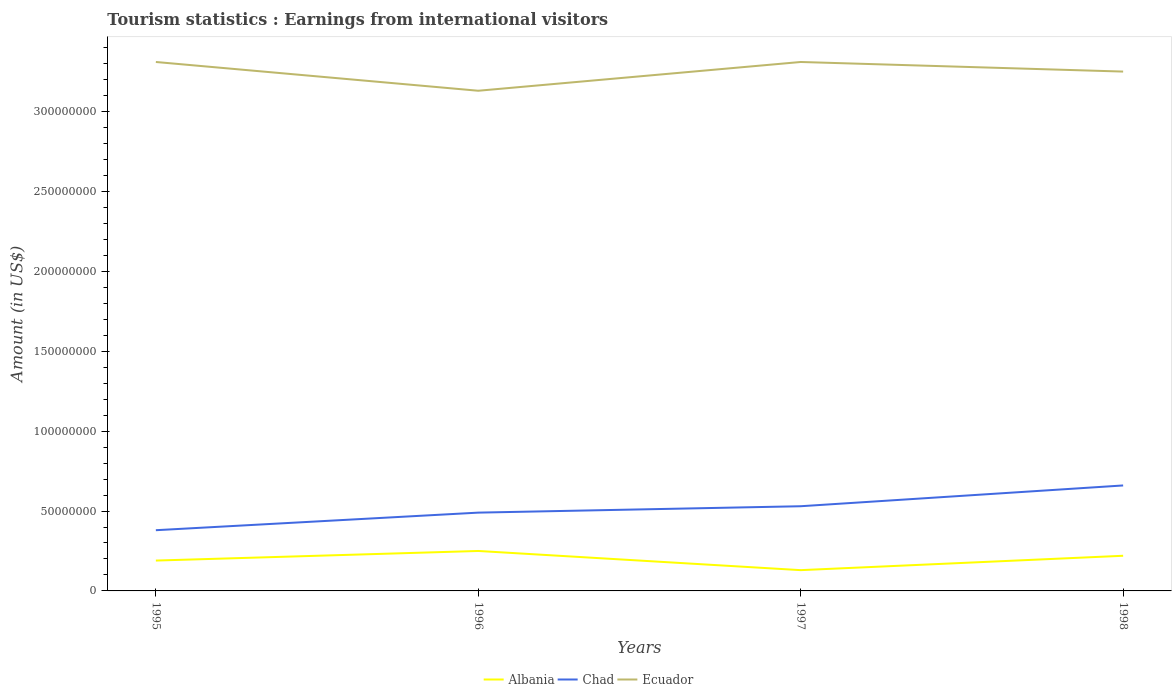How many different coloured lines are there?
Your response must be concise. 3. Does the line corresponding to Albania intersect with the line corresponding to Chad?
Keep it short and to the point. No. Across all years, what is the maximum earnings from international visitors in Albania?
Your response must be concise. 1.30e+07. In which year was the earnings from international visitors in Chad maximum?
Keep it short and to the point. 1995. What is the total earnings from international visitors in Chad in the graph?
Offer a very short reply. -1.30e+07. What is the difference between the highest and the second highest earnings from international visitors in Chad?
Your answer should be compact. 2.80e+07. What is the difference between the highest and the lowest earnings from international visitors in Chad?
Your answer should be very brief. 2. Is the earnings from international visitors in Albania strictly greater than the earnings from international visitors in Chad over the years?
Your answer should be very brief. Yes. How many lines are there?
Provide a short and direct response. 3. What is the difference between two consecutive major ticks on the Y-axis?
Your response must be concise. 5.00e+07. Are the values on the major ticks of Y-axis written in scientific E-notation?
Give a very brief answer. No. Does the graph contain grids?
Offer a very short reply. No. Where does the legend appear in the graph?
Your answer should be very brief. Bottom center. How many legend labels are there?
Give a very brief answer. 3. What is the title of the graph?
Make the answer very short. Tourism statistics : Earnings from international visitors. What is the label or title of the X-axis?
Make the answer very short. Years. What is the Amount (in US$) of Albania in 1995?
Keep it short and to the point. 1.90e+07. What is the Amount (in US$) in Chad in 1995?
Offer a very short reply. 3.80e+07. What is the Amount (in US$) of Ecuador in 1995?
Make the answer very short. 3.31e+08. What is the Amount (in US$) in Albania in 1996?
Keep it short and to the point. 2.50e+07. What is the Amount (in US$) of Chad in 1996?
Ensure brevity in your answer.  4.90e+07. What is the Amount (in US$) in Ecuador in 1996?
Give a very brief answer. 3.13e+08. What is the Amount (in US$) in Albania in 1997?
Offer a very short reply. 1.30e+07. What is the Amount (in US$) of Chad in 1997?
Give a very brief answer. 5.30e+07. What is the Amount (in US$) of Ecuador in 1997?
Provide a short and direct response. 3.31e+08. What is the Amount (in US$) of Albania in 1998?
Give a very brief answer. 2.20e+07. What is the Amount (in US$) of Chad in 1998?
Keep it short and to the point. 6.60e+07. What is the Amount (in US$) in Ecuador in 1998?
Provide a succinct answer. 3.25e+08. Across all years, what is the maximum Amount (in US$) of Albania?
Provide a succinct answer. 2.50e+07. Across all years, what is the maximum Amount (in US$) of Chad?
Provide a short and direct response. 6.60e+07. Across all years, what is the maximum Amount (in US$) in Ecuador?
Make the answer very short. 3.31e+08. Across all years, what is the minimum Amount (in US$) in Albania?
Offer a very short reply. 1.30e+07. Across all years, what is the minimum Amount (in US$) of Chad?
Your response must be concise. 3.80e+07. Across all years, what is the minimum Amount (in US$) of Ecuador?
Keep it short and to the point. 3.13e+08. What is the total Amount (in US$) in Albania in the graph?
Provide a succinct answer. 7.90e+07. What is the total Amount (in US$) in Chad in the graph?
Make the answer very short. 2.06e+08. What is the total Amount (in US$) of Ecuador in the graph?
Provide a short and direct response. 1.30e+09. What is the difference between the Amount (in US$) of Albania in 1995 and that in 1996?
Provide a succinct answer. -6.00e+06. What is the difference between the Amount (in US$) of Chad in 1995 and that in 1996?
Offer a terse response. -1.10e+07. What is the difference between the Amount (in US$) in Ecuador in 1995 and that in 1996?
Your response must be concise. 1.80e+07. What is the difference between the Amount (in US$) in Chad in 1995 and that in 1997?
Ensure brevity in your answer.  -1.50e+07. What is the difference between the Amount (in US$) of Albania in 1995 and that in 1998?
Make the answer very short. -3.00e+06. What is the difference between the Amount (in US$) of Chad in 1995 and that in 1998?
Keep it short and to the point. -2.80e+07. What is the difference between the Amount (in US$) of Ecuador in 1996 and that in 1997?
Provide a succinct answer. -1.80e+07. What is the difference between the Amount (in US$) in Chad in 1996 and that in 1998?
Provide a short and direct response. -1.70e+07. What is the difference between the Amount (in US$) of Ecuador in 1996 and that in 1998?
Provide a succinct answer. -1.20e+07. What is the difference between the Amount (in US$) in Albania in 1997 and that in 1998?
Your answer should be very brief. -9.00e+06. What is the difference between the Amount (in US$) of Chad in 1997 and that in 1998?
Offer a very short reply. -1.30e+07. What is the difference between the Amount (in US$) in Ecuador in 1997 and that in 1998?
Ensure brevity in your answer.  6.00e+06. What is the difference between the Amount (in US$) in Albania in 1995 and the Amount (in US$) in Chad in 1996?
Ensure brevity in your answer.  -3.00e+07. What is the difference between the Amount (in US$) of Albania in 1995 and the Amount (in US$) of Ecuador in 1996?
Your answer should be very brief. -2.94e+08. What is the difference between the Amount (in US$) in Chad in 1995 and the Amount (in US$) in Ecuador in 1996?
Offer a terse response. -2.75e+08. What is the difference between the Amount (in US$) of Albania in 1995 and the Amount (in US$) of Chad in 1997?
Provide a succinct answer. -3.40e+07. What is the difference between the Amount (in US$) in Albania in 1995 and the Amount (in US$) in Ecuador in 1997?
Give a very brief answer. -3.12e+08. What is the difference between the Amount (in US$) of Chad in 1995 and the Amount (in US$) of Ecuador in 1997?
Make the answer very short. -2.93e+08. What is the difference between the Amount (in US$) of Albania in 1995 and the Amount (in US$) of Chad in 1998?
Offer a very short reply. -4.70e+07. What is the difference between the Amount (in US$) in Albania in 1995 and the Amount (in US$) in Ecuador in 1998?
Keep it short and to the point. -3.06e+08. What is the difference between the Amount (in US$) of Chad in 1995 and the Amount (in US$) of Ecuador in 1998?
Your answer should be very brief. -2.87e+08. What is the difference between the Amount (in US$) in Albania in 1996 and the Amount (in US$) in Chad in 1997?
Provide a short and direct response. -2.80e+07. What is the difference between the Amount (in US$) in Albania in 1996 and the Amount (in US$) in Ecuador in 1997?
Provide a succinct answer. -3.06e+08. What is the difference between the Amount (in US$) in Chad in 1996 and the Amount (in US$) in Ecuador in 1997?
Offer a terse response. -2.82e+08. What is the difference between the Amount (in US$) in Albania in 1996 and the Amount (in US$) in Chad in 1998?
Keep it short and to the point. -4.10e+07. What is the difference between the Amount (in US$) of Albania in 1996 and the Amount (in US$) of Ecuador in 1998?
Offer a terse response. -3.00e+08. What is the difference between the Amount (in US$) of Chad in 1996 and the Amount (in US$) of Ecuador in 1998?
Your answer should be very brief. -2.76e+08. What is the difference between the Amount (in US$) in Albania in 1997 and the Amount (in US$) in Chad in 1998?
Your response must be concise. -5.30e+07. What is the difference between the Amount (in US$) in Albania in 1997 and the Amount (in US$) in Ecuador in 1998?
Offer a terse response. -3.12e+08. What is the difference between the Amount (in US$) in Chad in 1997 and the Amount (in US$) in Ecuador in 1998?
Give a very brief answer. -2.72e+08. What is the average Amount (in US$) of Albania per year?
Offer a very short reply. 1.98e+07. What is the average Amount (in US$) in Chad per year?
Offer a very short reply. 5.15e+07. What is the average Amount (in US$) of Ecuador per year?
Provide a succinct answer. 3.25e+08. In the year 1995, what is the difference between the Amount (in US$) of Albania and Amount (in US$) of Chad?
Your response must be concise. -1.90e+07. In the year 1995, what is the difference between the Amount (in US$) in Albania and Amount (in US$) in Ecuador?
Your response must be concise. -3.12e+08. In the year 1995, what is the difference between the Amount (in US$) in Chad and Amount (in US$) in Ecuador?
Offer a very short reply. -2.93e+08. In the year 1996, what is the difference between the Amount (in US$) in Albania and Amount (in US$) in Chad?
Offer a terse response. -2.40e+07. In the year 1996, what is the difference between the Amount (in US$) of Albania and Amount (in US$) of Ecuador?
Offer a terse response. -2.88e+08. In the year 1996, what is the difference between the Amount (in US$) in Chad and Amount (in US$) in Ecuador?
Ensure brevity in your answer.  -2.64e+08. In the year 1997, what is the difference between the Amount (in US$) of Albania and Amount (in US$) of Chad?
Offer a terse response. -4.00e+07. In the year 1997, what is the difference between the Amount (in US$) in Albania and Amount (in US$) in Ecuador?
Provide a succinct answer. -3.18e+08. In the year 1997, what is the difference between the Amount (in US$) of Chad and Amount (in US$) of Ecuador?
Your answer should be very brief. -2.78e+08. In the year 1998, what is the difference between the Amount (in US$) in Albania and Amount (in US$) in Chad?
Keep it short and to the point. -4.40e+07. In the year 1998, what is the difference between the Amount (in US$) of Albania and Amount (in US$) of Ecuador?
Your response must be concise. -3.03e+08. In the year 1998, what is the difference between the Amount (in US$) of Chad and Amount (in US$) of Ecuador?
Keep it short and to the point. -2.59e+08. What is the ratio of the Amount (in US$) in Albania in 1995 to that in 1996?
Keep it short and to the point. 0.76. What is the ratio of the Amount (in US$) in Chad in 1995 to that in 1996?
Your answer should be compact. 0.78. What is the ratio of the Amount (in US$) of Ecuador in 1995 to that in 1996?
Offer a terse response. 1.06. What is the ratio of the Amount (in US$) of Albania in 1995 to that in 1997?
Offer a very short reply. 1.46. What is the ratio of the Amount (in US$) of Chad in 1995 to that in 1997?
Make the answer very short. 0.72. What is the ratio of the Amount (in US$) in Albania in 1995 to that in 1998?
Your answer should be very brief. 0.86. What is the ratio of the Amount (in US$) in Chad in 1995 to that in 1998?
Offer a terse response. 0.58. What is the ratio of the Amount (in US$) in Ecuador in 1995 to that in 1998?
Provide a succinct answer. 1.02. What is the ratio of the Amount (in US$) in Albania in 1996 to that in 1997?
Provide a short and direct response. 1.92. What is the ratio of the Amount (in US$) in Chad in 1996 to that in 1997?
Give a very brief answer. 0.92. What is the ratio of the Amount (in US$) of Ecuador in 1996 to that in 1997?
Your response must be concise. 0.95. What is the ratio of the Amount (in US$) in Albania in 1996 to that in 1998?
Your answer should be very brief. 1.14. What is the ratio of the Amount (in US$) of Chad in 1996 to that in 1998?
Keep it short and to the point. 0.74. What is the ratio of the Amount (in US$) of Ecuador in 1996 to that in 1998?
Provide a succinct answer. 0.96. What is the ratio of the Amount (in US$) in Albania in 1997 to that in 1998?
Your answer should be very brief. 0.59. What is the ratio of the Amount (in US$) of Chad in 1997 to that in 1998?
Your response must be concise. 0.8. What is the ratio of the Amount (in US$) in Ecuador in 1997 to that in 1998?
Make the answer very short. 1.02. What is the difference between the highest and the second highest Amount (in US$) of Albania?
Keep it short and to the point. 3.00e+06. What is the difference between the highest and the second highest Amount (in US$) in Chad?
Ensure brevity in your answer.  1.30e+07. What is the difference between the highest and the lowest Amount (in US$) in Albania?
Provide a short and direct response. 1.20e+07. What is the difference between the highest and the lowest Amount (in US$) of Chad?
Your answer should be compact. 2.80e+07. What is the difference between the highest and the lowest Amount (in US$) in Ecuador?
Keep it short and to the point. 1.80e+07. 